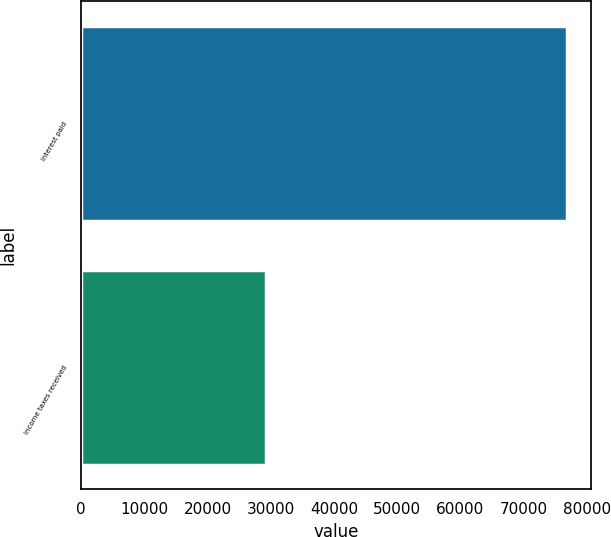<chart> <loc_0><loc_0><loc_500><loc_500><bar_chart><fcel>Interest paid<fcel>Income taxes received<nl><fcel>76833<fcel>29251<nl></chart> 